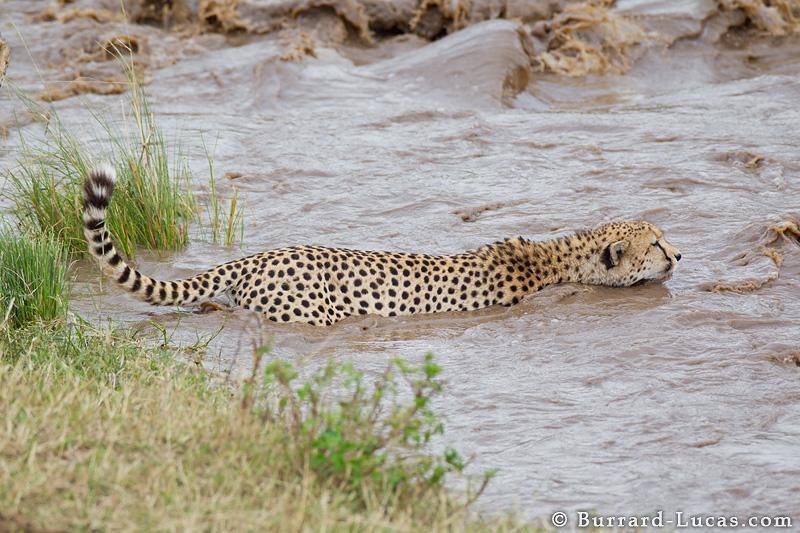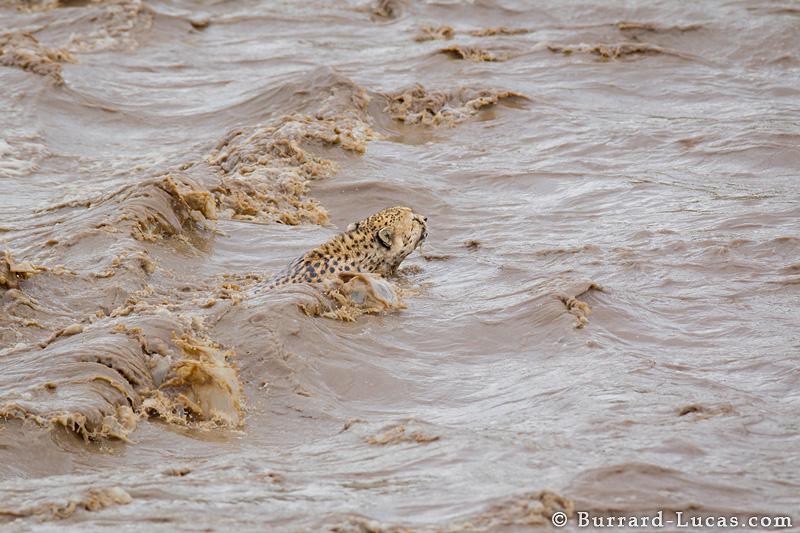The first image is the image on the left, the second image is the image on the right. Analyze the images presented: Is the assertion "The left image has a cheetah that is approaching the shore." valid? Answer yes or no. No. 